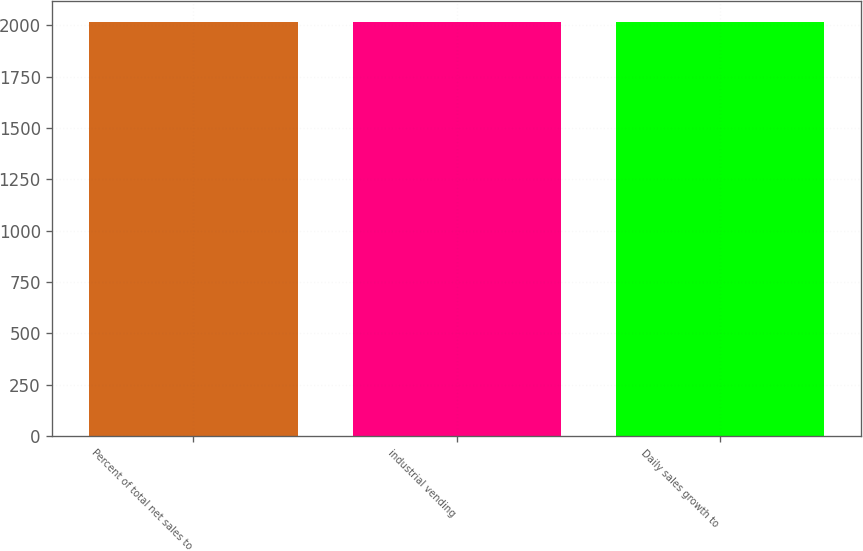<chart> <loc_0><loc_0><loc_500><loc_500><bar_chart><fcel>Percent of total net sales to<fcel>industrial vending<fcel>Daily sales growth to<nl><fcel>2016<fcel>2015<fcel>2016.1<nl></chart> 